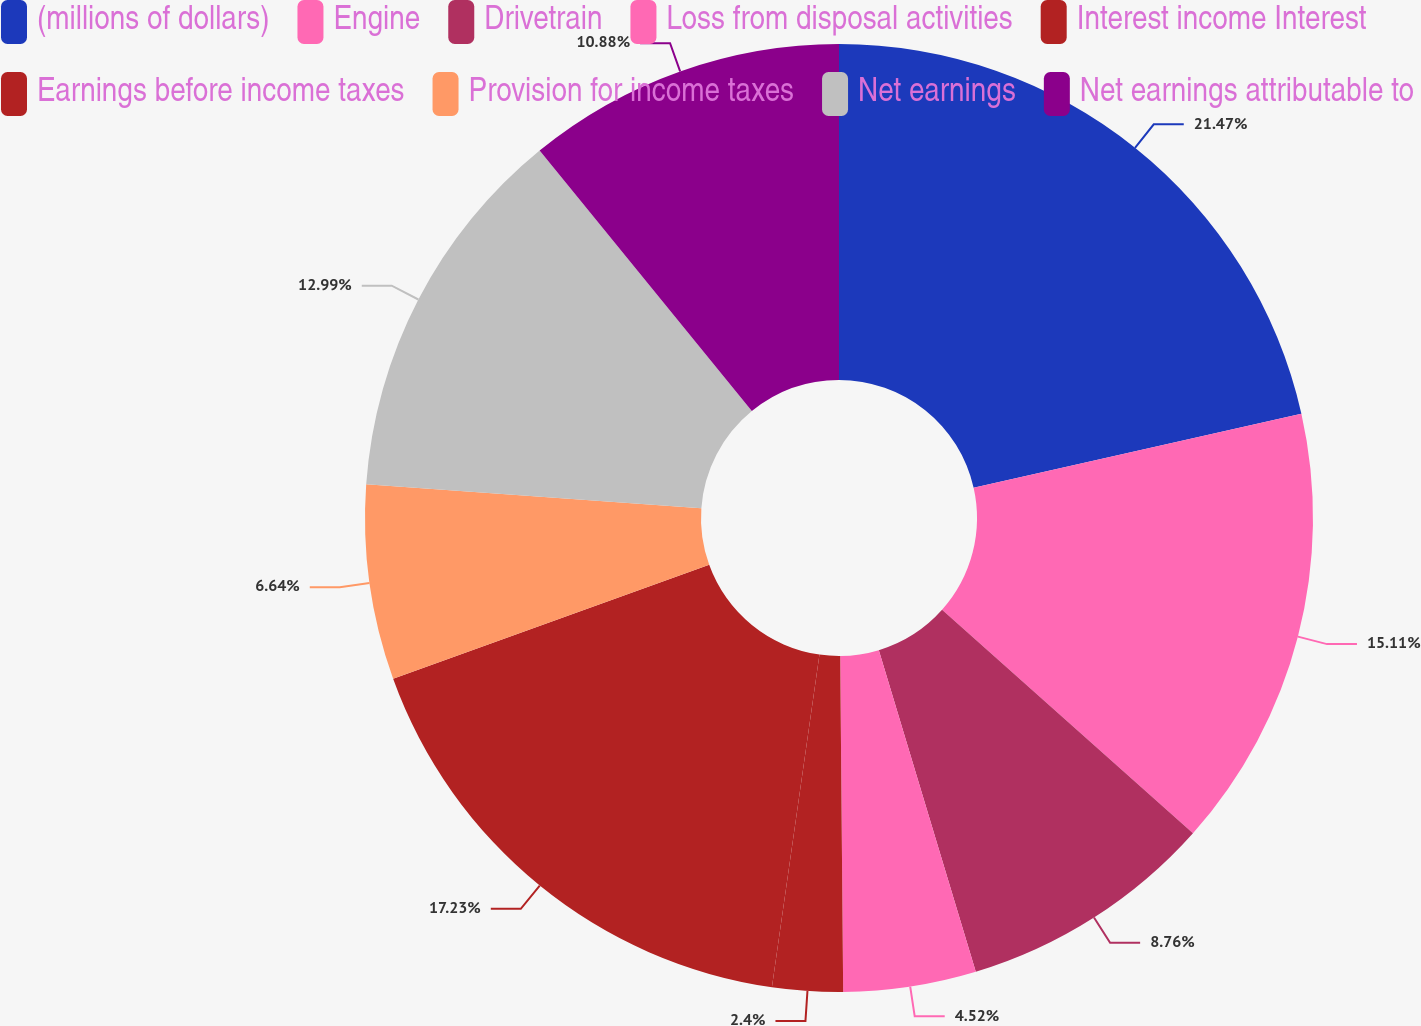Convert chart to OTSL. <chart><loc_0><loc_0><loc_500><loc_500><pie_chart><fcel>(millions of dollars)<fcel>Engine<fcel>Drivetrain<fcel>Loss from disposal activities<fcel>Interest income Interest<fcel>Earnings before income taxes<fcel>Provision for income taxes<fcel>Net earnings<fcel>Net earnings attributable to<nl><fcel>21.47%<fcel>15.11%<fcel>8.76%<fcel>4.52%<fcel>2.4%<fcel>17.23%<fcel>6.64%<fcel>12.99%<fcel>10.88%<nl></chart> 